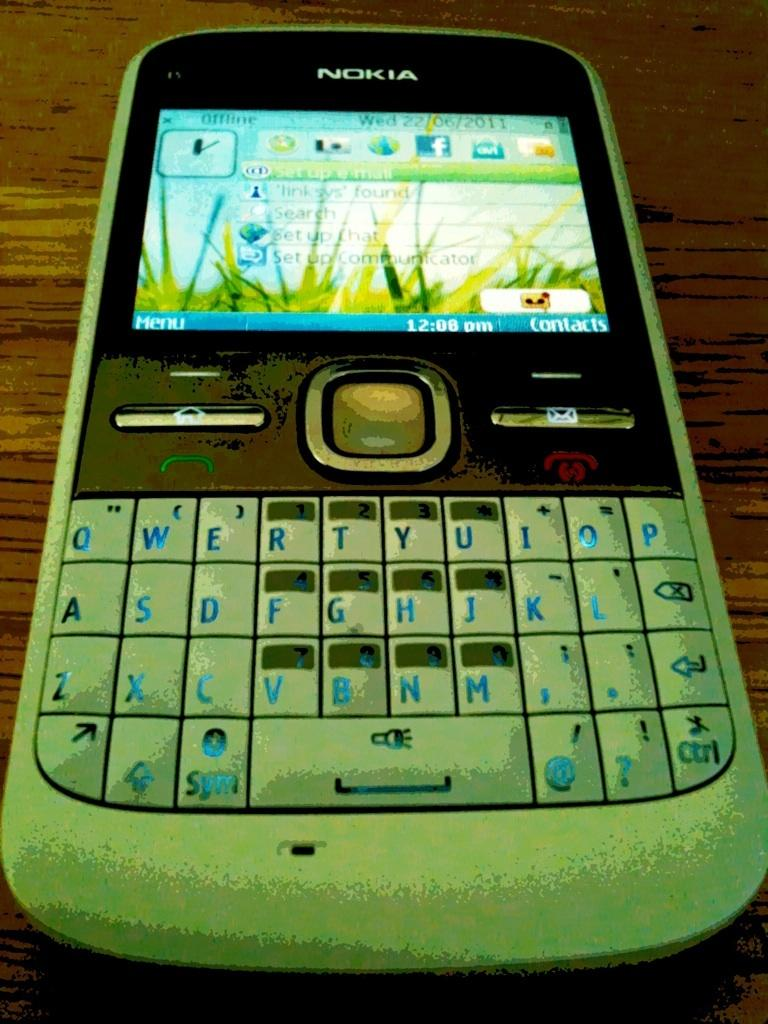<image>
Create a compact narrative representing the image presented. A cell phone from the brand Nokia is on a wooden surface. 